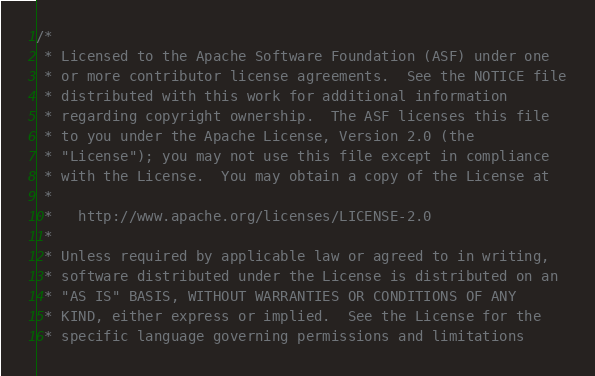Convert code to text. <code><loc_0><loc_0><loc_500><loc_500><_Cuda_>/*
 * Licensed to the Apache Software Foundation (ASF) under one
 * or more contributor license agreements.  See the NOTICE file
 * distributed with this work for additional information
 * regarding copyright ownership.  The ASF licenses this file
 * to you under the Apache License, Version 2.0 (the
 * "License"); you may not use this file except in compliance
 * with the License.  You may obtain a copy of the License at
 *
 *   http://www.apache.org/licenses/LICENSE-2.0
 *
 * Unless required by applicable law or agreed to in writing,
 * software distributed under the License is distributed on an
 * "AS IS" BASIS, WITHOUT WARRANTIES OR CONDITIONS OF ANY
 * KIND, either express or implied.  See the License for the
 * specific language governing permissions and limitations</code> 